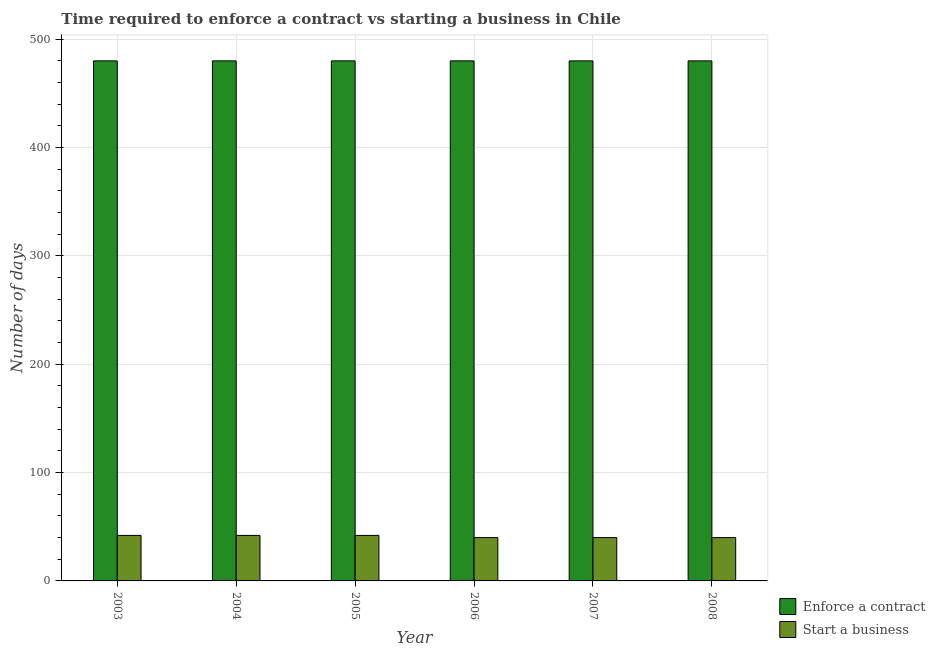How many different coloured bars are there?
Provide a short and direct response. 2. How many groups of bars are there?
Your answer should be very brief. 6. Are the number of bars on each tick of the X-axis equal?
Provide a short and direct response. Yes. How many bars are there on the 1st tick from the left?
Provide a succinct answer. 2. What is the label of the 6th group of bars from the left?
Your answer should be compact. 2008. In how many cases, is the number of bars for a given year not equal to the number of legend labels?
Your answer should be very brief. 0. What is the number of days to enforece a contract in 2007?
Make the answer very short. 480. Across all years, what is the maximum number of days to enforece a contract?
Offer a very short reply. 480. In which year was the number of days to start a business minimum?
Make the answer very short. 2006. What is the total number of days to start a business in the graph?
Give a very brief answer. 246. What is the difference between the number of days to start a business in 2005 and that in 2007?
Offer a very short reply. 2. What is the average number of days to start a business per year?
Keep it short and to the point. 41. What is the ratio of the number of days to start a business in 2005 to that in 2007?
Keep it short and to the point. 1.05. What is the difference between the highest and the second highest number of days to enforece a contract?
Your answer should be very brief. 0. In how many years, is the number of days to enforece a contract greater than the average number of days to enforece a contract taken over all years?
Offer a very short reply. 0. Is the sum of the number of days to start a business in 2003 and 2008 greater than the maximum number of days to enforece a contract across all years?
Provide a short and direct response. Yes. What does the 1st bar from the left in 2003 represents?
Give a very brief answer. Enforce a contract. What does the 2nd bar from the right in 2003 represents?
Offer a very short reply. Enforce a contract. How many bars are there?
Ensure brevity in your answer.  12. How many years are there in the graph?
Provide a succinct answer. 6. What is the difference between two consecutive major ticks on the Y-axis?
Provide a short and direct response. 100. Are the values on the major ticks of Y-axis written in scientific E-notation?
Make the answer very short. No. Does the graph contain any zero values?
Provide a short and direct response. No. Does the graph contain grids?
Provide a succinct answer. Yes. Where does the legend appear in the graph?
Keep it short and to the point. Bottom right. How many legend labels are there?
Your answer should be very brief. 2. How are the legend labels stacked?
Give a very brief answer. Vertical. What is the title of the graph?
Offer a terse response. Time required to enforce a contract vs starting a business in Chile. What is the label or title of the X-axis?
Give a very brief answer. Year. What is the label or title of the Y-axis?
Your response must be concise. Number of days. What is the Number of days in Enforce a contract in 2003?
Give a very brief answer. 480. What is the Number of days in Enforce a contract in 2004?
Keep it short and to the point. 480. What is the Number of days of Enforce a contract in 2005?
Keep it short and to the point. 480. What is the Number of days in Start a business in 2005?
Ensure brevity in your answer.  42. What is the Number of days of Enforce a contract in 2006?
Provide a succinct answer. 480. What is the Number of days in Start a business in 2006?
Your answer should be very brief. 40. What is the Number of days in Enforce a contract in 2007?
Your answer should be very brief. 480. What is the Number of days in Start a business in 2007?
Your answer should be very brief. 40. What is the Number of days in Enforce a contract in 2008?
Your response must be concise. 480. Across all years, what is the maximum Number of days in Enforce a contract?
Your response must be concise. 480. Across all years, what is the maximum Number of days of Start a business?
Provide a succinct answer. 42. Across all years, what is the minimum Number of days of Enforce a contract?
Offer a terse response. 480. Across all years, what is the minimum Number of days in Start a business?
Your answer should be compact. 40. What is the total Number of days of Enforce a contract in the graph?
Provide a short and direct response. 2880. What is the total Number of days in Start a business in the graph?
Offer a very short reply. 246. What is the difference between the Number of days of Enforce a contract in 2003 and that in 2004?
Ensure brevity in your answer.  0. What is the difference between the Number of days in Start a business in 2003 and that in 2004?
Make the answer very short. 0. What is the difference between the Number of days in Start a business in 2003 and that in 2006?
Keep it short and to the point. 2. What is the difference between the Number of days in Enforce a contract in 2003 and that in 2007?
Offer a terse response. 0. What is the difference between the Number of days in Start a business in 2003 and that in 2007?
Offer a very short reply. 2. What is the difference between the Number of days in Start a business in 2004 and that in 2005?
Offer a very short reply. 0. What is the difference between the Number of days in Enforce a contract in 2004 and that in 2007?
Your answer should be compact. 0. What is the difference between the Number of days of Start a business in 2004 and that in 2007?
Offer a very short reply. 2. What is the difference between the Number of days of Start a business in 2004 and that in 2008?
Make the answer very short. 2. What is the difference between the Number of days in Enforce a contract in 2005 and that in 2007?
Offer a terse response. 0. What is the difference between the Number of days in Enforce a contract in 2006 and that in 2007?
Your answer should be compact. 0. What is the difference between the Number of days in Enforce a contract in 2006 and that in 2008?
Give a very brief answer. 0. What is the difference between the Number of days in Start a business in 2006 and that in 2008?
Provide a short and direct response. 0. What is the difference between the Number of days of Enforce a contract in 2007 and that in 2008?
Offer a very short reply. 0. What is the difference between the Number of days of Enforce a contract in 2003 and the Number of days of Start a business in 2004?
Make the answer very short. 438. What is the difference between the Number of days of Enforce a contract in 2003 and the Number of days of Start a business in 2005?
Provide a short and direct response. 438. What is the difference between the Number of days in Enforce a contract in 2003 and the Number of days in Start a business in 2006?
Make the answer very short. 440. What is the difference between the Number of days in Enforce a contract in 2003 and the Number of days in Start a business in 2007?
Provide a short and direct response. 440. What is the difference between the Number of days in Enforce a contract in 2003 and the Number of days in Start a business in 2008?
Provide a succinct answer. 440. What is the difference between the Number of days in Enforce a contract in 2004 and the Number of days in Start a business in 2005?
Give a very brief answer. 438. What is the difference between the Number of days of Enforce a contract in 2004 and the Number of days of Start a business in 2006?
Give a very brief answer. 440. What is the difference between the Number of days in Enforce a contract in 2004 and the Number of days in Start a business in 2007?
Keep it short and to the point. 440. What is the difference between the Number of days of Enforce a contract in 2004 and the Number of days of Start a business in 2008?
Provide a short and direct response. 440. What is the difference between the Number of days in Enforce a contract in 2005 and the Number of days in Start a business in 2006?
Your response must be concise. 440. What is the difference between the Number of days in Enforce a contract in 2005 and the Number of days in Start a business in 2007?
Provide a short and direct response. 440. What is the difference between the Number of days in Enforce a contract in 2005 and the Number of days in Start a business in 2008?
Offer a terse response. 440. What is the difference between the Number of days of Enforce a contract in 2006 and the Number of days of Start a business in 2007?
Provide a short and direct response. 440. What is the difference between the Number of days of Enforce a contract in 2006 and the Number of days of Start a business in 2008?
Provide a succinct answer. 440. What is the difference between the Number of days in Enforce a contract in 2007 and the Number of days in Start a business in 2008?
Offer a terse response. 440. What is the average Number of days in Enforce a contract per year?
Your answer should be compact. 480. What is the average Number of days in Start a business per year?
Provide a short and direct response. 41. In the year 2003, what is the difference between the Number of days in Enforce a contract and Number of days in Start a business?
Your answer should be very brief. 438. In the year 2004, what is the difference between the Number of days in Enforce a contract and Number of days in Start a business?
Provide a succinct answer. 438. In the year 2005, what is the difference between the Number of days in Enforce a contract and Number of days in Start a business?
Offer a very short reply. 438. In the year 2006, what is the difference between the Number of days of Enforce a contract and Number of days of Start a business?
Provide a short and direct response. 440. In the year 2007, what is the difference between the Number of days of Enforce a contract and Number of days of Start a business?
Your response must be concise. 440. In the year 2008, what is the difference between the Number of days in Enforce a contract and Number of days in Start a business?
Offer a very short reply. 440. What is the ratio of the Number of days in Start a business in 2003 to that in 2004?
Your response must be concise. 1. What is the ratio of the Number of days of Enforce a contract in 2003 to that in 2006?
Ensure brevity in your answer.  1. What is the ratio of the Number of days in Enforce a contract in 2003 to that in 2007?
Keep it short and to the point. 1. What is the ratio of the Number of days in Start a business in 2003 to that in 2007?
Keep it short and to the point. 1.05. What is the ratio of the Number of days in Start a business in 2003 to that in 2008?
Keep it short and to the point. 1.05. What is the ratio of the Number of days in Enforce a contract in 2004 to that in 2006?
Your response must be concise. 1. What is the ratio of the Number of days of Enforce a contract in 2004 to that in 2007?
Ensure brevity in your answer.  1. What is the ratio of the Number of days in Enforce a contract in 2004 to that in 2008?
Your answer should be compact. 1. What is the ratio of the Number of days of Start a business in 2004 to that in 2008?
Ensure brevity in your answer.  1.05. What is the ratio of the Number of days in Enforce a contract in 2005 to that in 2006?
Keep it short and to the point. 1. What is the ratio of the Number of days in Start a business in 2005 to that in 2006?
Provide a succinct answer. 1.05. What is the ratio of the Number of days in Enforce a contract in 2005 to that in 2007?
Your answer should be very brief. 1. What is the ratio of the Number of days in Enforce a contract in 2005 to that in 2008?
Offer a terse response. 1. What is the ratio of the Number of days of Start a business in 2005 to that in 2008?
Offer a very short reply. 1.05. What is the ratio of the Number of days in Enforce a contract in 2006 to that in 2007?
Offer a terse response. 1. What is the ratio of the Number of days of Start a business in 2006 to that in 2007?
Your answer should be compact. 1. What is the ratio of the Number of days of Enforce a contract in 2007 to that in 2008?
Your response must be concise. 1. What is the ratio of the Number of days in Start a business in 2007 to that in 2008?
Your answer should be very brief. 1. What is the difference between the highest and the lowest Number of days of Enforce a contract?
Offer a terse response. 0. What is the difference between the highest and the lowest Number of days of Start a business?
Give a very brief answer. 2. 